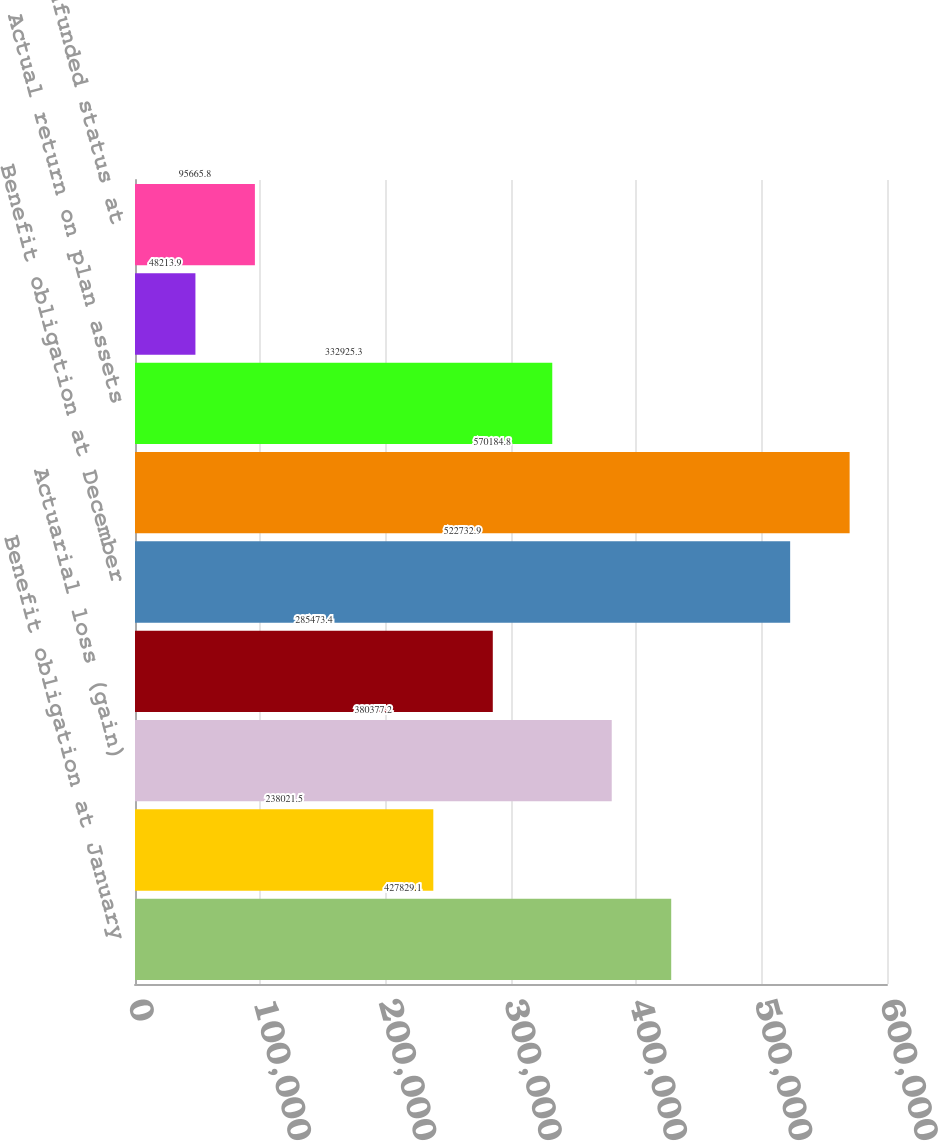Convert chart to OTSL. <chart><loc_0><loc_0><loc_500><loc_500><bar_chart><fcel>Benefit obligation at January<fcel>Interest cost<fcel>Actuarial loss (gain)<fcel>Benefits paid<fcel>Benefit obligation at December<fcel>Fair value of plan assets at<fcel>Actual return on plan assets<fcel>Employer contributions net<fcel>(Funded) unfunded status at<nl><fcel>427829<fcel>238022<fcel>380377<fcel>285473<fcel>522733<fcel>570185<fcel>332925<fcel>48213.9<fcel>95665.8<nl></chart> 